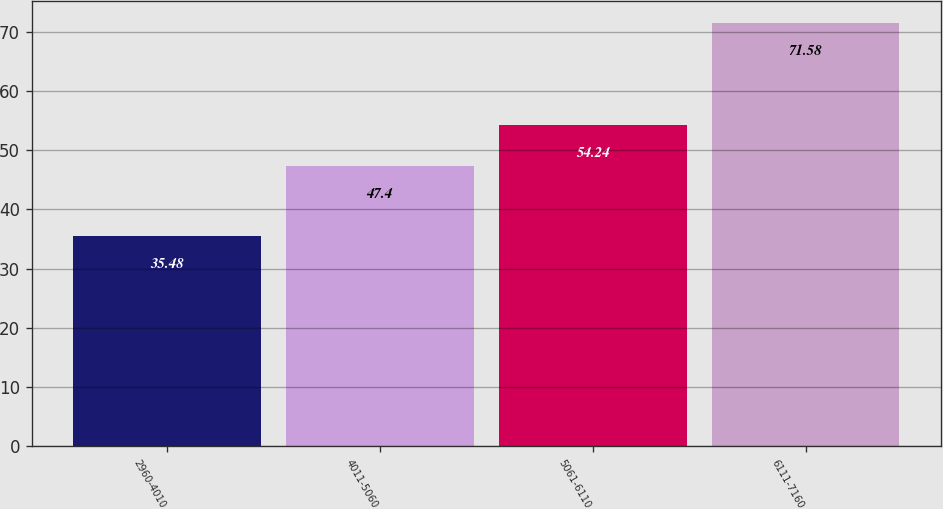<chart> <loc_0><loc_0><loc_500><loc_500><bar_chart><fcel>2960-4010<fcel>4011-5060<fcel>5061-6110<fcel>6111-7160<nl><fcel>35.48<fcel>47.4<fcel>54.24<fcel>71.58<nl></chart> 